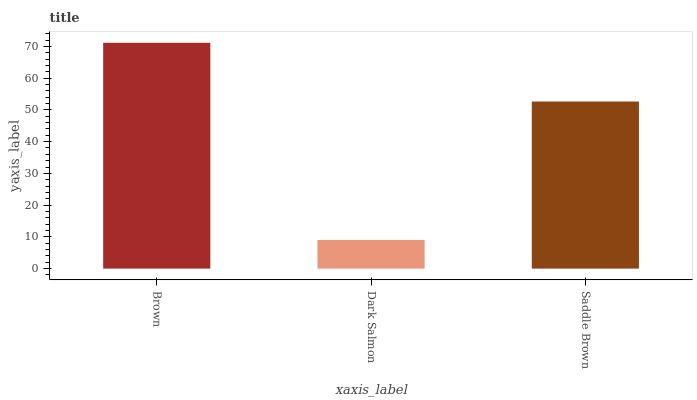Is Dark Salmon the minimum?
Answer yes or no. Yes. Is Brown the maximum?
Answer yes or no. Yes. Is Saddle Brown the minimum?
Answer yes or no. No. Is Saddle Brown the maximum?
Answer yes or no. No. Is Saddle Brown greater than Dark Salmon?
Answer yes or no. Yes. Is Dark Salmon less than Saddle Brown?
Answer yes or no. Yes. Is Dark Salmon greater than Saddle Brown?
Answer yes or no. No. Is Saddle Brown less than Dark Salmon?
Answer yes or no. No. Is Saddle Brown the high median?
Answer yes or no. Yes. Is Saddle Brown the low median?
Answer yes or no. Yes. Is Dark Salmon the high median?
Answer yes or no. No. Is Brown the low median?
Answer yes or no. No. 